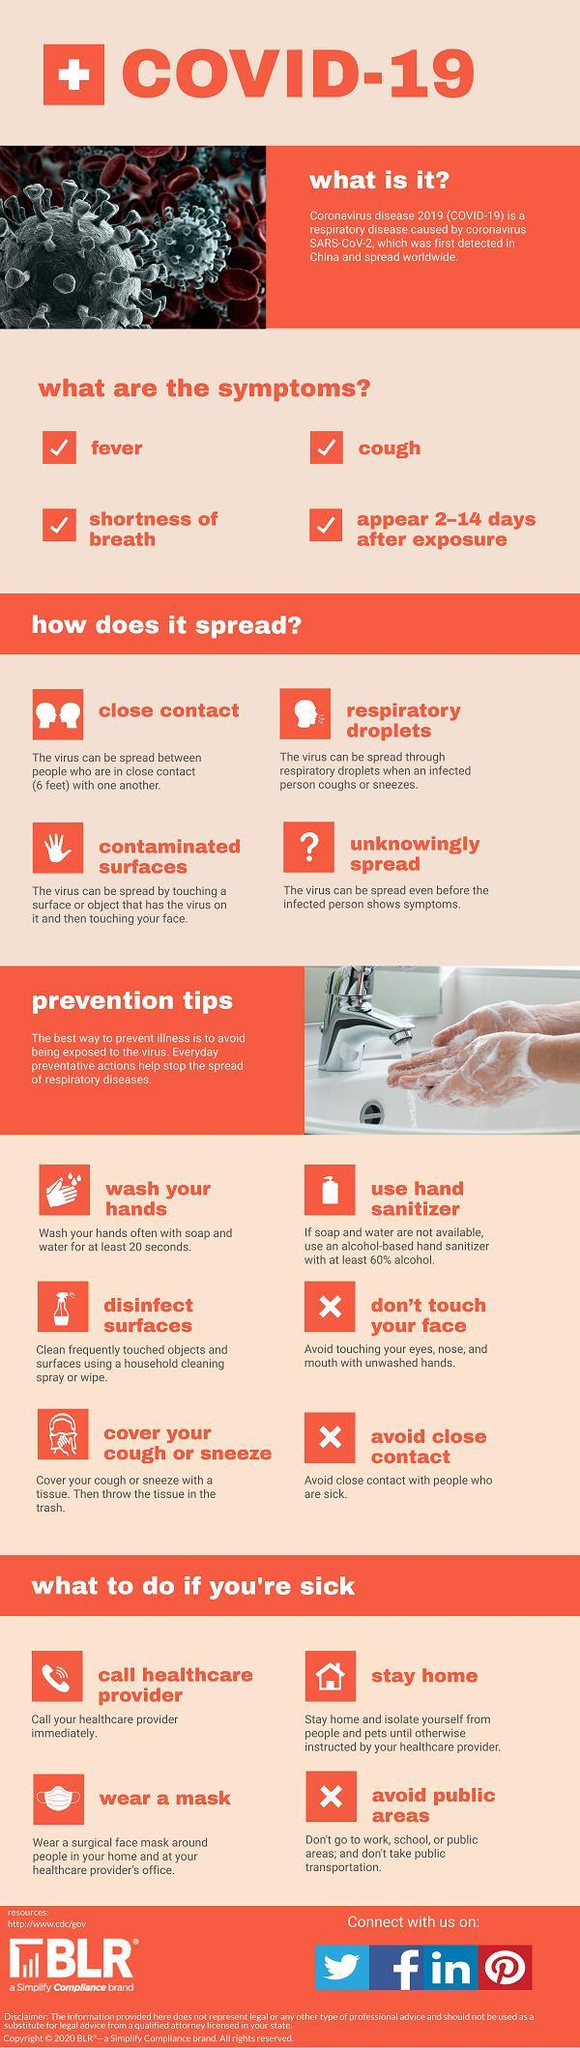What is the incubation period of the COVID-19 virus?
Answer the question with a short phrase. 2-14 days What percent of alcohol the hand sanitizer should contain in order to control the spread of COVID-19 virus? at least 60% alcohol. How long one should wash their hands in order to prevent the spread of COVID-19? at least 20 seconds What is the minimum safe distance to be maintained between yourself & others inorder to control the spread of COVID-19 virus? (6 feet) 